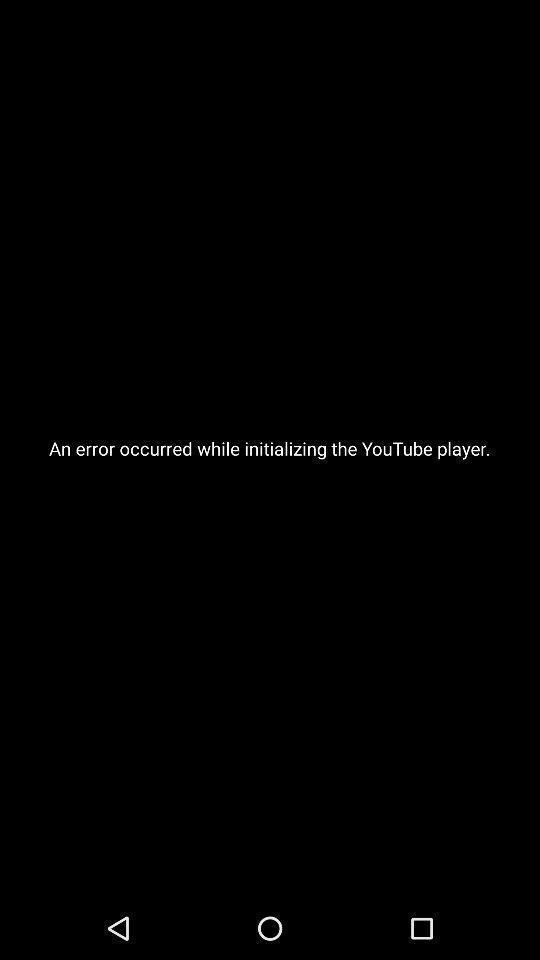Explain the elements present in this screenshot. Page displaying of an error while streaming video player app. 